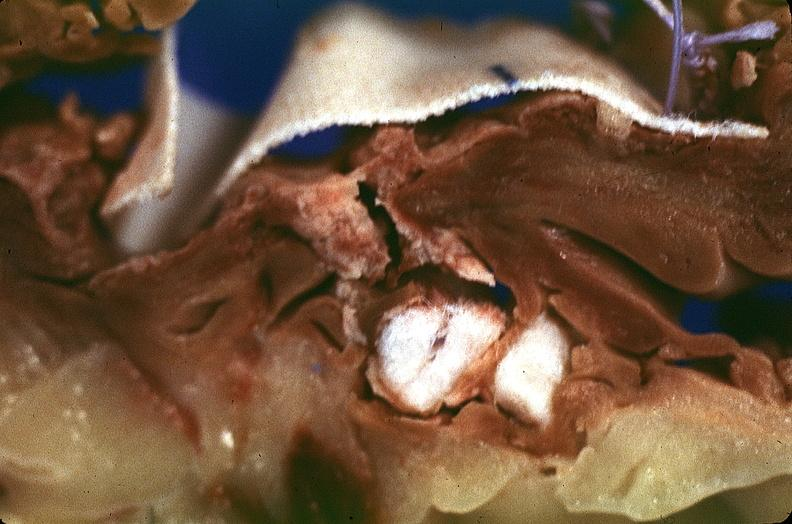does this image show heart, myocardial infarction, surgery to repair interventricular septum rupture?
Answer the question using a single word or phrase. Yes 